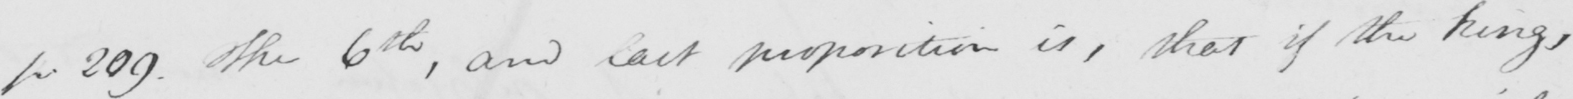What does this handwritten line say? p 209 . The 6th , and last proposition is , that if the kings , 